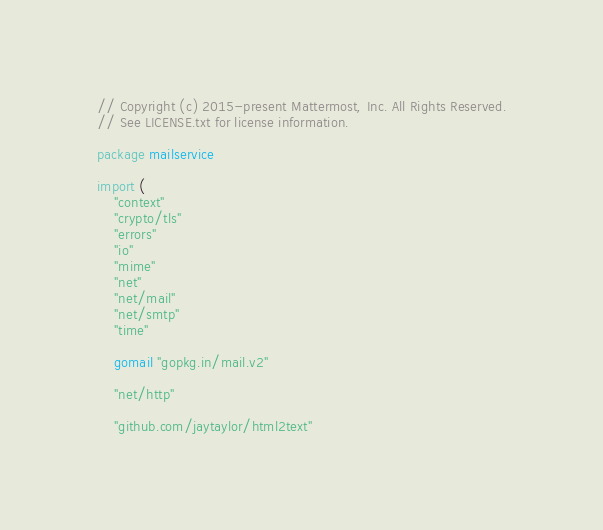Convert code to text. <code><loc_0><loc_0><loc_500><loc_500><_Go_>// Copyright (c) 2015-present Mattermost, Inc. All Rights Reserved.
// See LICENSE.txt for license information.

package mailservice

import (
	"context"
	"crypto/tls"
	"errors"
	"io"
	"mime"
	"net"
	"net/mail"
	"net/smtp"
	"time"

	gomail "gopkg.in/mail.v2"

	"net/http"

	"github.com/jaytaylor/html2text"</code> 